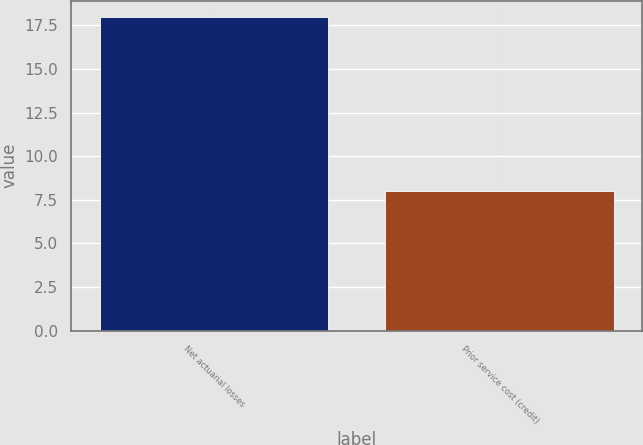Convert chart to OTSL. <chart><loc_0><loc_0><loc_500><loc_500><bar_chart><fcel>Net actuarial losses<fcel>Prior service cost (credit)<nl><fcel>18<fcel>8<nl></chart> 